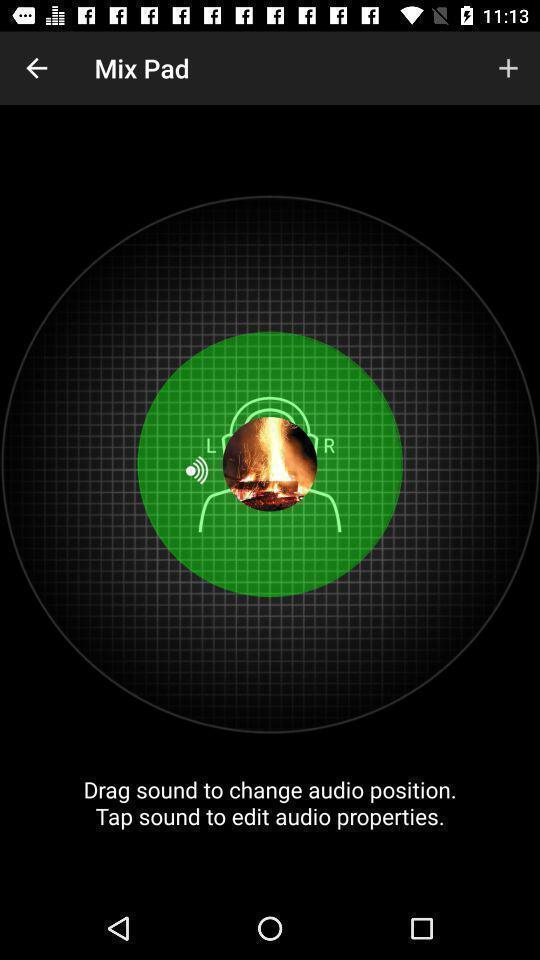What can you discern from this picture? Page displaying the different options of mix pad. 